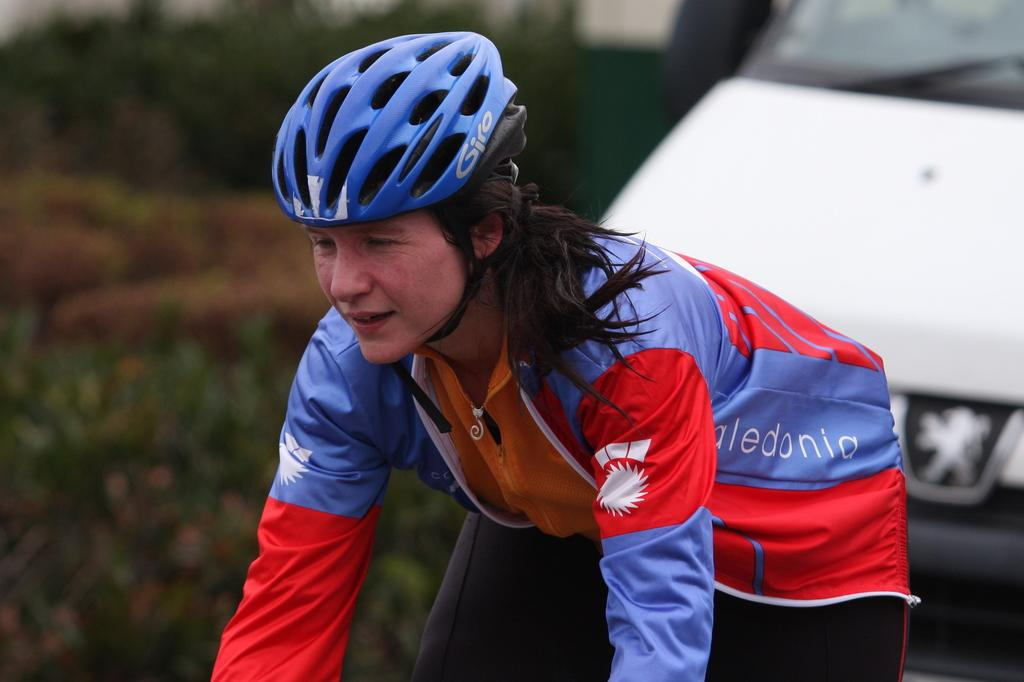Who is present in the image? There is a woman in the image. What is the woman wearing on her head? The woman is wearing a helmet. What type of vegetation can be seen in the image? There are plants visible in the image. What type of vehicle is present in the image? There is a car in the image. What type of agreement is the woman signing in the image? There is no indication in the image that the woman is signing any agreement. 